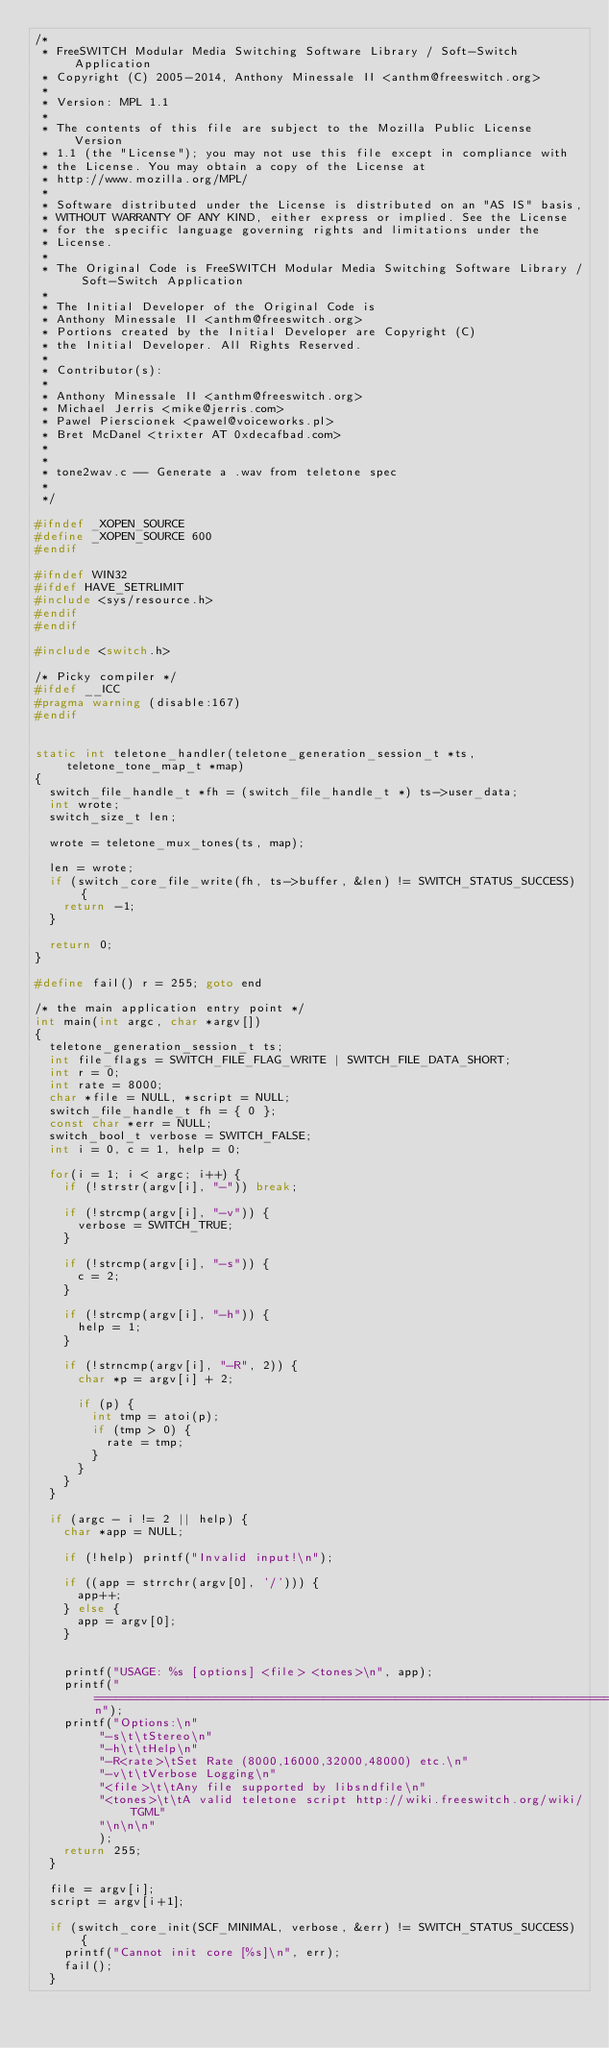<code> <loc_0><loc_0><loc_500><loc_500><_C_>/* 
 * FreeSWITCH Modular Media Switching Software Library / Soft-Switch Application
 * Copyright (C) 2005-2014, Anthony Minessale II <anthm@freeswitch.org>
 *
 * Version: MPL 1.1
 *
 * The contents of this file are subject to the Mozilla Public License Version
 * 1.1 (the "License"); you may not use this file except in compliance with
 * the License. You may obtain a copy of the License at
 * http://www.mozilla.org/MPL/
 *
 * Software distributed under the License is distributed on an "AS IS" basis,
 * WITHOUT WARRANTY OF ANY KIND, either express or implied. See the License
 * for the specific language governing rights and limitations under the
 * License.
 *
 * The Original Code is FreeSWITCH Modular Media Switching Software Library / Soft-Switch Application
 *
 * The Initial Developer of the Original Code is
 * Anthony Minessale II <anthm@freeswitch.org>
 * Portions created by the Initial Developer are Copyright (C)
 * the Initial Developer. All Rights Reserved.
 *
 * Contributor(s):
 * 
 * Anthony Minessale II <anthm@freeswitch.org>
 * Michael Jerris <mike@jerris.com>
 * Pawel Pierscionek <pawel@voiceworks.pl>
 * Bret McDanel <trixter AT 0xdecafbad.com>
 *
 *
 * tone2wav.c -- Generate a .wav from teletone spec
 *
 */

#ifndef _XOPEN_SOURCE
#define _XOPEN_SOURCE 600
#endif

#ifndef WIN32
#ifdef HAVE_SETRLIMIT
#include <sys/resource.h>
#endif
#endif

#include <switch.h>

/* Picky compiler */
#ifdef __ICC
#pragma warning (disable:167)
#endif


static int teletone_handler(teletone_generation_session_t *ts, teletone_tone_map_t *map)
{
	switch_file_handle_t *fh = (switch_file_handle_t *) ts->user_data;
	int wrote;
	switch_size_t len;

	wrote = teletone_mux_tones(ts, map);

	len = wrote;
	if (switch_core_file_write(fh, ts->buffer, &len) != SWITCH_STATUS_SUCCESS) {
		return -1;
	}

	return 0;
}

#define fail() r = 255; goto end

/* the main application entry point */
int main(int argc, char *argv[])
{
	teletone_generation_session_t ts;
	int file_flags = SWITCH_FILE_FLAG_WRITE | SWITCH_FILE_DATA_SHORT;
	int r = 0;
	int rate = 8000;
	char *file = NULL, *script = NULL;
	switch_file_handle_t fh = { 0 };
	const char *err = NULL;
	switch_bool_t verbose = SWITCH_FALSE;
	int i = 0, c = 1, help = 0;

	for(i = 1; i < argc; i++) {
		if (!strstr(argv[i], "-")) break;
		
		if (!strcmp(argv[i], "-v")) {
			verbose = SWITCH_TRUE;
		}

		if (!strcmp(argv[i], "-s")) {
			c = 2;
		}

		if (!strcmp(argv[i], "-h")) {
			help = 1;
		}

		if (!strncmp(argv[i], "-R", 2)) {
			char *p = argv[i] + 2;

			if (p) {
				int tmp = atoi(p);
				if (tmp > 0) {
					rate = tmp;
				}
			}
		}
	}

	if (argc - i != 2 || help) {
		char *app = NULL;

		if (!help) printf("Invalid input!\n");

		if ((app = strrchr(argv[0], '/'))) {
			app++;
		} else {
			app = argv[0];
		}


		printf("USAGE: %s [options] <file> <tones>\n", app);
		printf("================================================================================\n");
		printf("Options:\n"
			   "-s\t\tStereo\n"
			   "-h\t\tHelp\n"
			   "-R<rate>\tSet Rate (8000,16000,32000,48000) etc.\n"
			   "-v\t\tVerbose Logging\n"
			   "<file>\t\tAny file supported by libsndfile\n"
			   "<tones>\t\tA valid teletone script http://wiki.freeswitch.org/wiki/TGML"
			   "\n\n\n"
			   );
		return 255;
	}
	
	file = argv[i];
	script = argv[i+1];

	if (switch_core_init(SCF_MINIMAL, verbose, &err) != SWITCH_STATUS_SUCCESS) {
		printf("Cannot init core [%s]\n", err);
		fail();
	}
</code> 